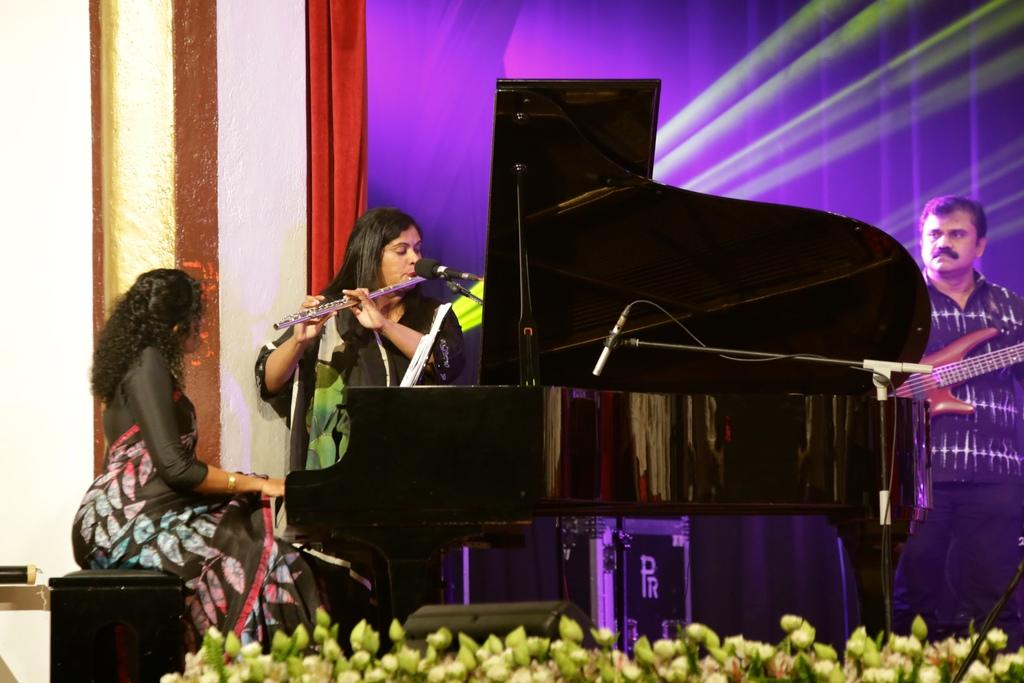How many people are in the image? There are three people in the image. What are the people in the image doing? The three people are playing musical instruments. Can you describe the instruments being played? One person is playing the piano, another is playing the flute, and the third person is playing the guitar. Where are the people performing? They are performing on a stage. Can you see any rifles in the image? No, there are no rifles present in the image. Is there a cellar visible in the image? No, there is no cellar visible in the image. 